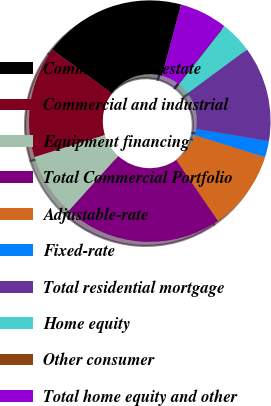Convert chart to OTSL. <chart><loc_0><loc_0><loc_500><loc_500><pie_chart><fcel>Commercial real estate<fcel>Commercial and industrial<fcel>Equipment financing<fcel>Total Commercial Portfolio<fcel>Adjustable-rate<fcel>Fixed-rate<fcel>Total residential mortgage<fcel>Home equity<fcel>Other consumer<fcel>Total home equity and other<nl><fcel>19.12%<fcel>14.88%<fcel>8.52%<fcel>21.24%<fcel>10.64%<fcel>2.16%<fcel>12.76%<fcel>4.28%<fcel>0.04%<fcel>6.4%<nl></chart> 